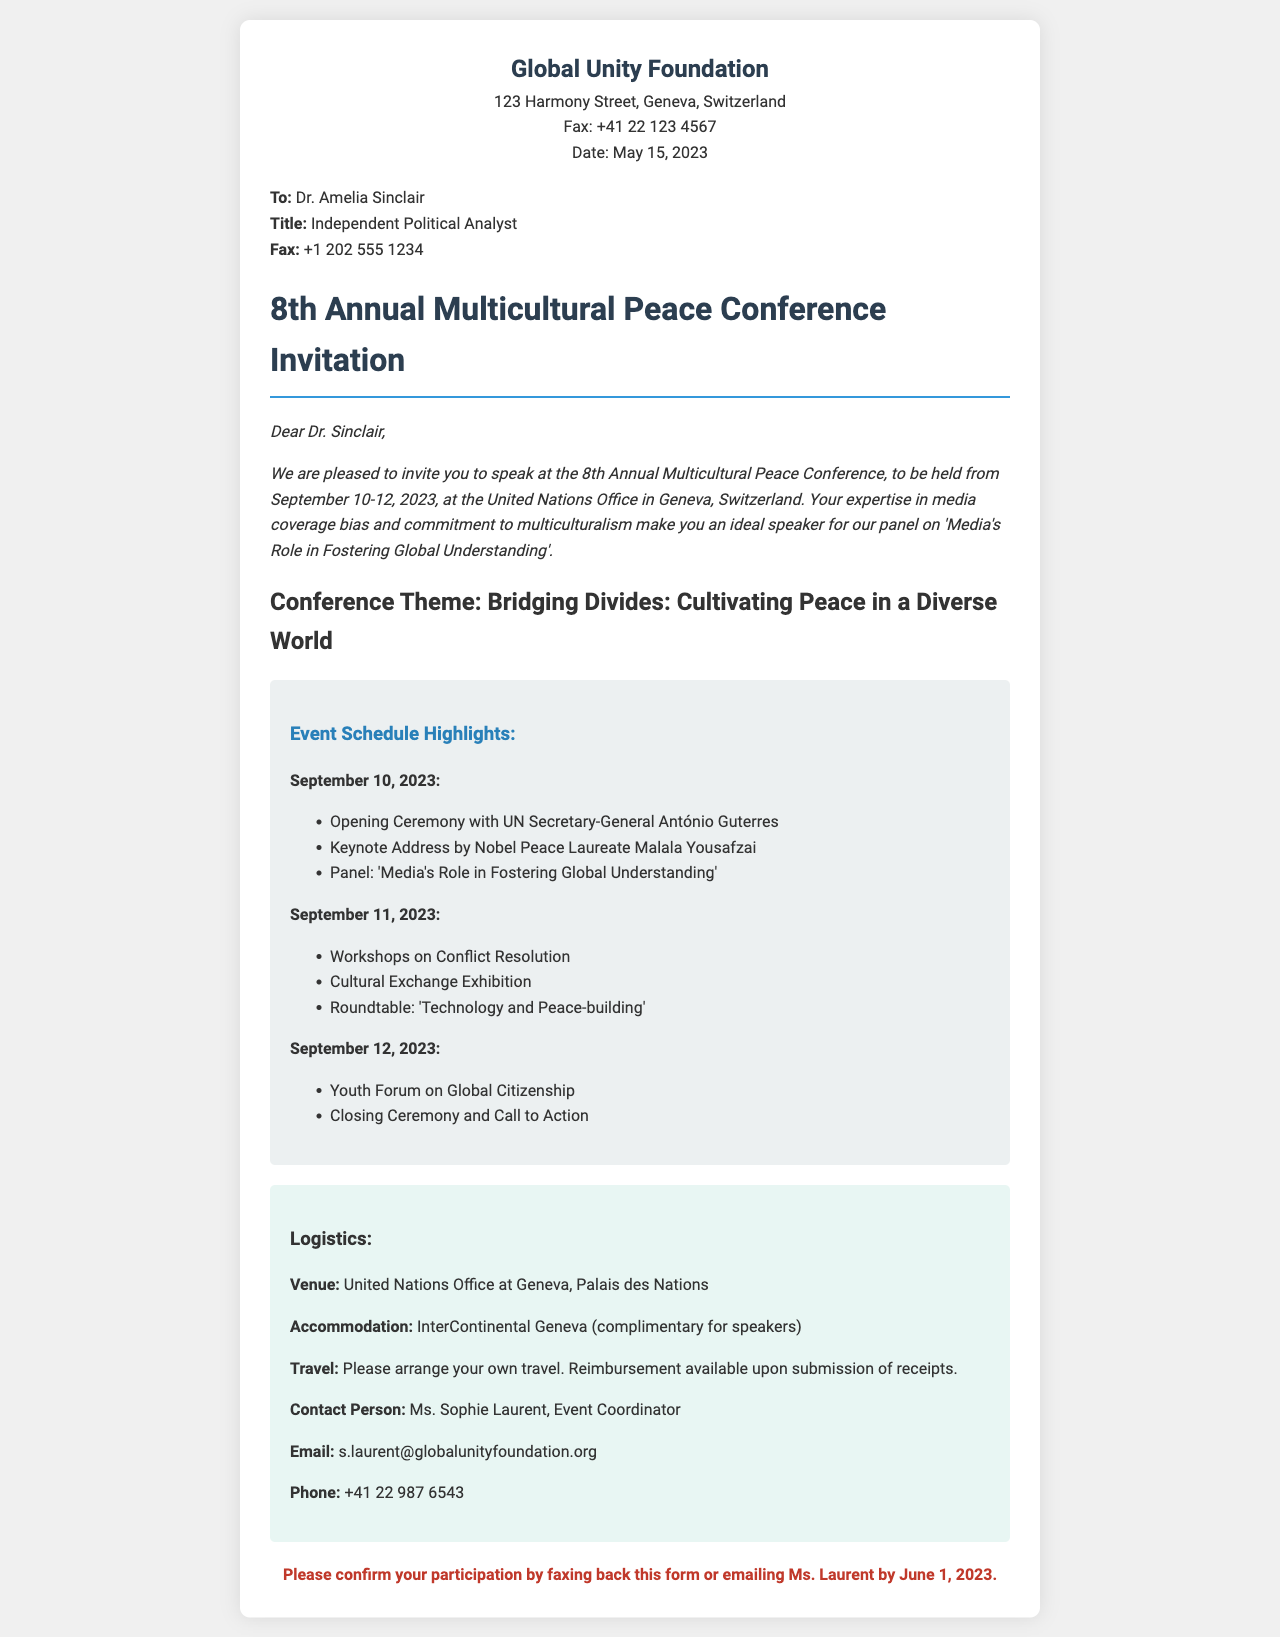What are the conference dates? The conference is scheduled to be held from September 10-12, 2023.
Answer: September 10-12, 2023 Who is the contact person for the event? The document specifies Ms. Sophie Laurent as the contact person for the event.
Answer: Ms. Sophie Laurent What is the title of the panel Dr. Sinclair is invited to? The panel that Dr. Sinclair is invited to speak on is about media's role in fostering global understanding.
Answer: Media's Role in Fostering Global Understanding What hotel will provide complimentary accommodation for speakers? The InterContinental Geneva is mentioned as the hotel that will offer complimentary accommodation for speakers.
Answer: InterContinental Geneva What is the theme of the conference? The theme of the conference is outlined in the document, focusing on cultivating peace in a diverse world.
Answer: Bridging Divides: Cultivating Peace in a Diverse World When is the deadline for confirming participation? The document states that the participation confirmation should be made by June 1, 2023.
Answer: June 1, 2023 How many days will the conference last? The conference will take place over three days, from September 10 to September 12.
Answer: Three days What is the opening event of the conference? The first event on the schedule is the Opening Ceremony with UN Secretary-General António Guterres.
Answer: Opening Ceremony with UN Secretary-General António Guterres 